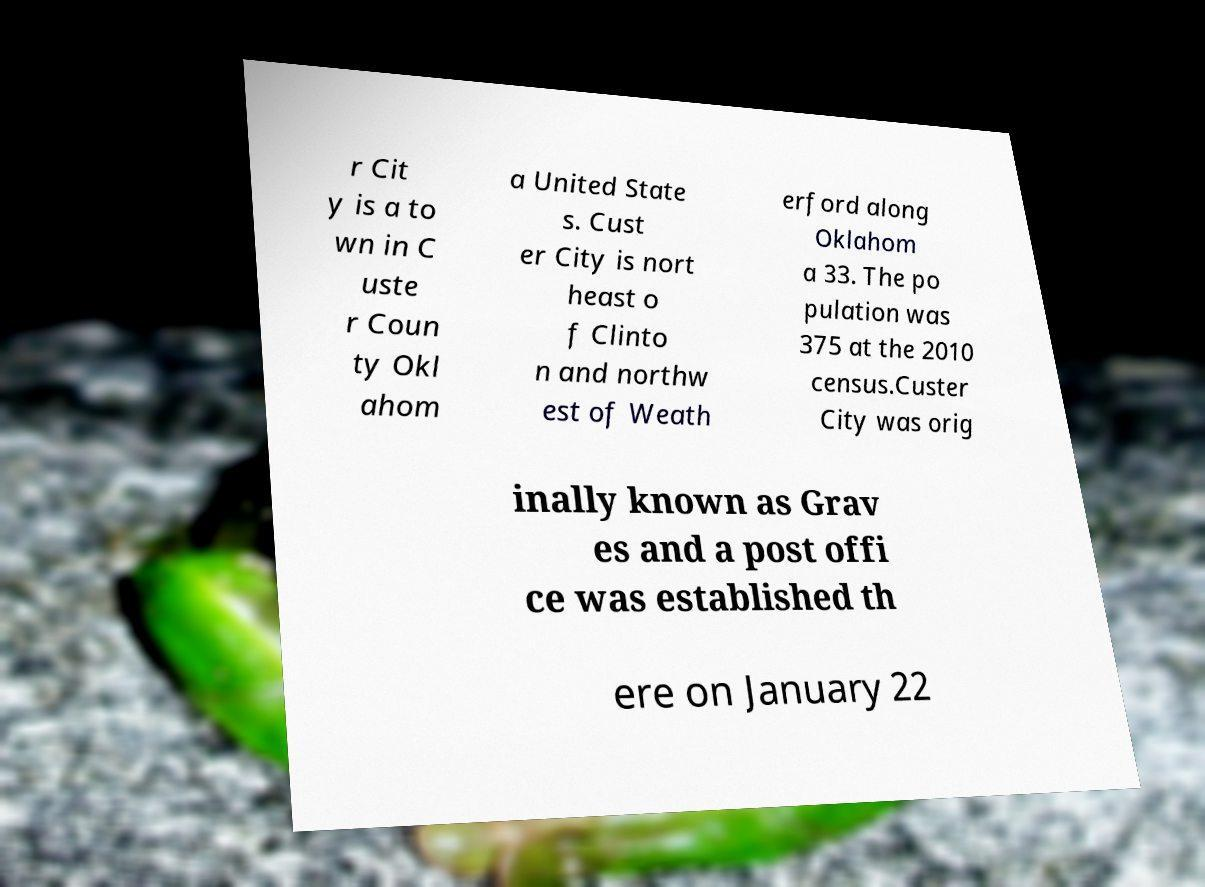I need the written content from this picture converted into text. Can you do that? r Cit y is a to wn in C uste r Coun ty Okl ahom a United State s. Cust er City is nort heast o f Clinto n and northw est of Weath erford along Oklahom a 33. The po pulation was 375 at the 2010 census.Custer City was orig inally known as Grav es and a post offi ce was established th ere on January 22 